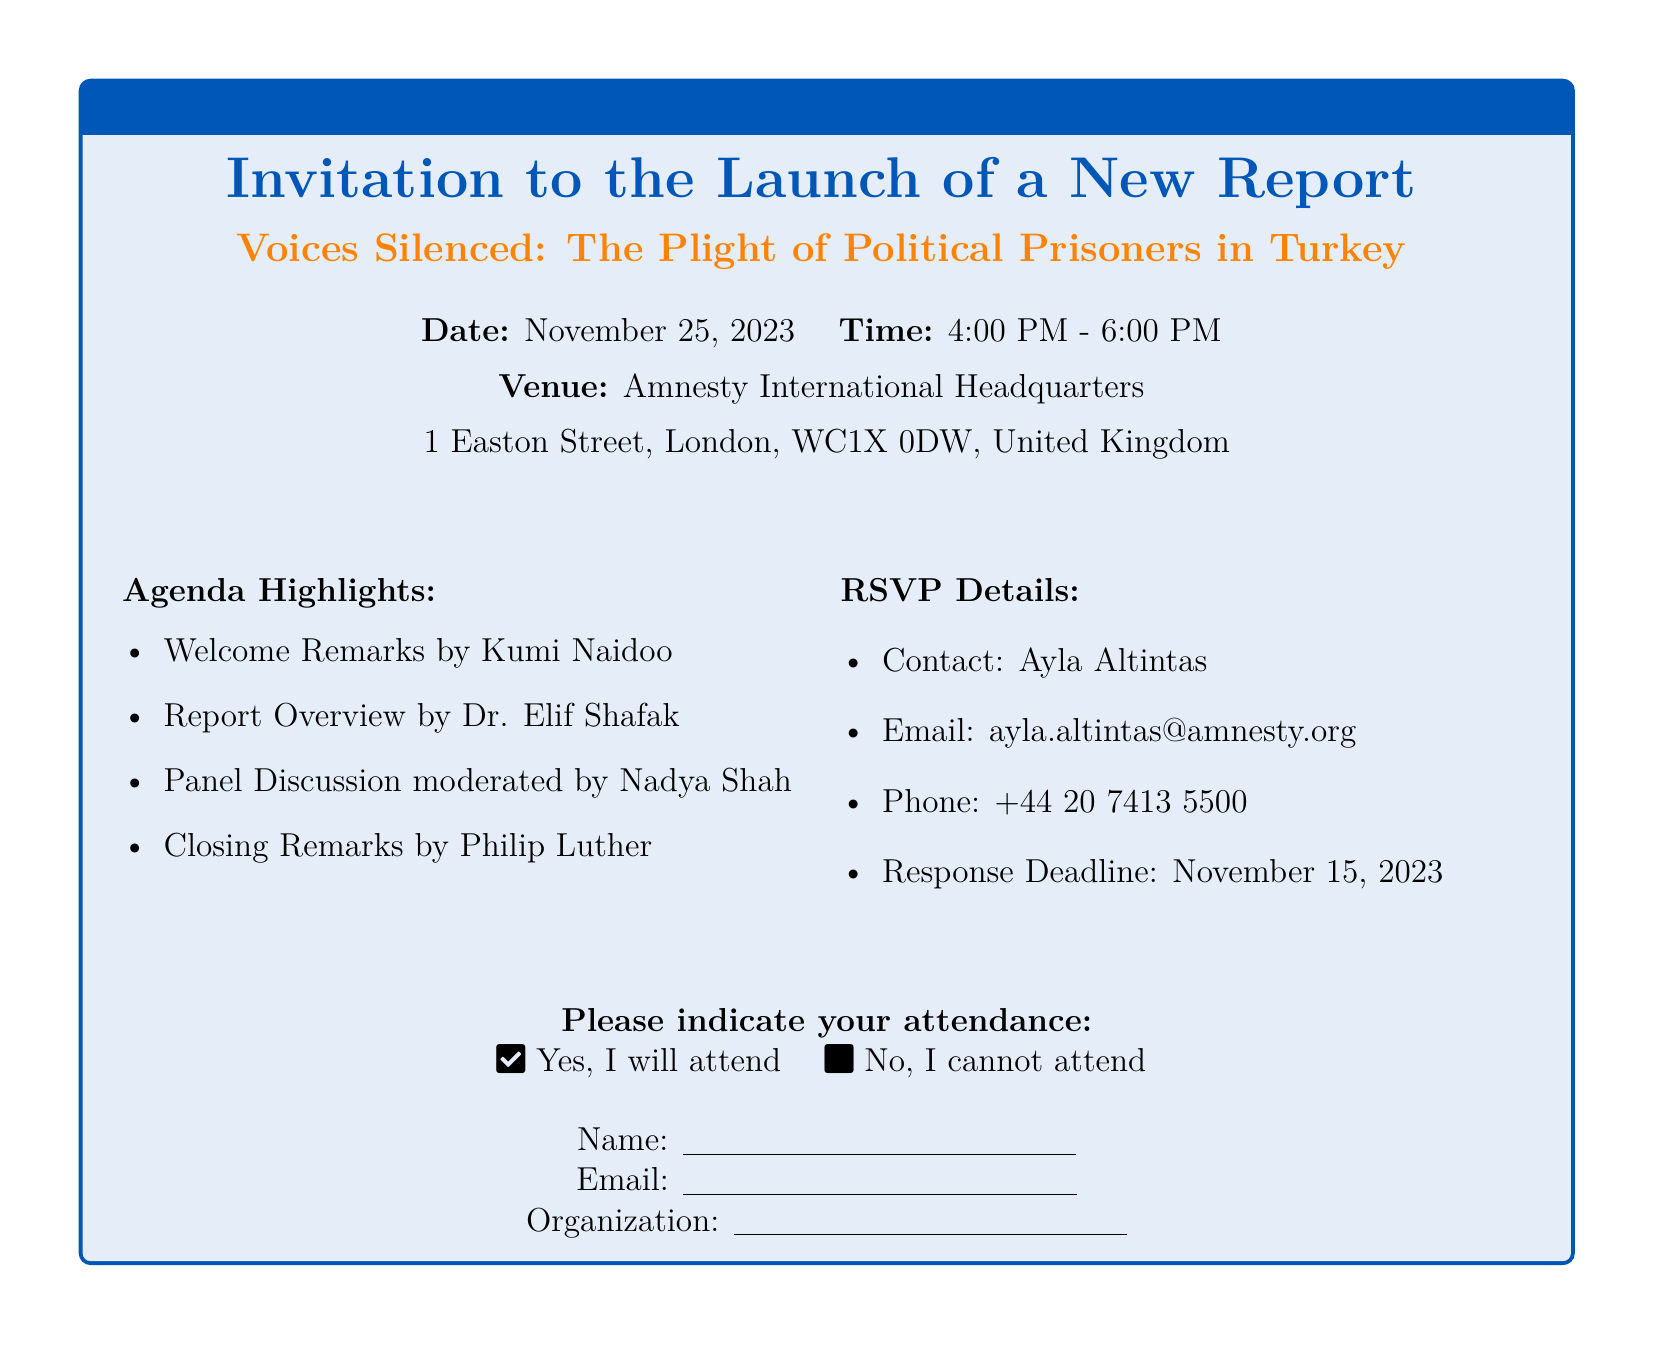What is the title of the report being launched? The title of the report is "Voices Silenced: The Plight of Political Prisoners in Turkey."
Answer: Voices Silenced: The Plight of Political Prisoners in Turkey What date is the report launch scheduled for? The document states that the report launch is on November 25, 2023.
Answer: November 25, 2023 Who will give the welcome remarks? The document mentions Kumi Naidoo will deliver the welcome remarks.
Answer: Kumi Naidoo What is the venue for the event? The venue for the launch is stated as Amnesty International Headquarters.
Answer: Amnesty International Headquarters Who is the contact person for RSVP? The document specifies that Ayla Altintas is the contact person for the RSVP.
Answer: Ayla Altintas What time does the event start? According to the document, the event starts at 4:00 PM.
Answer: 4:00 PM What is the response deadline for the RSVP? The response deadline for the RSVP is noted as November 15, 2023.
Answer: November 15, 2023 How long is the event scheduled to last? The document indicates that the event is scheduled from 4:00 PM to 6:00 PM, implying it will last for 2 hours.
Answer: 2 hours What type of event is this document for? The document is an RSVP card for a report launch event.
Answer: Report launch event 